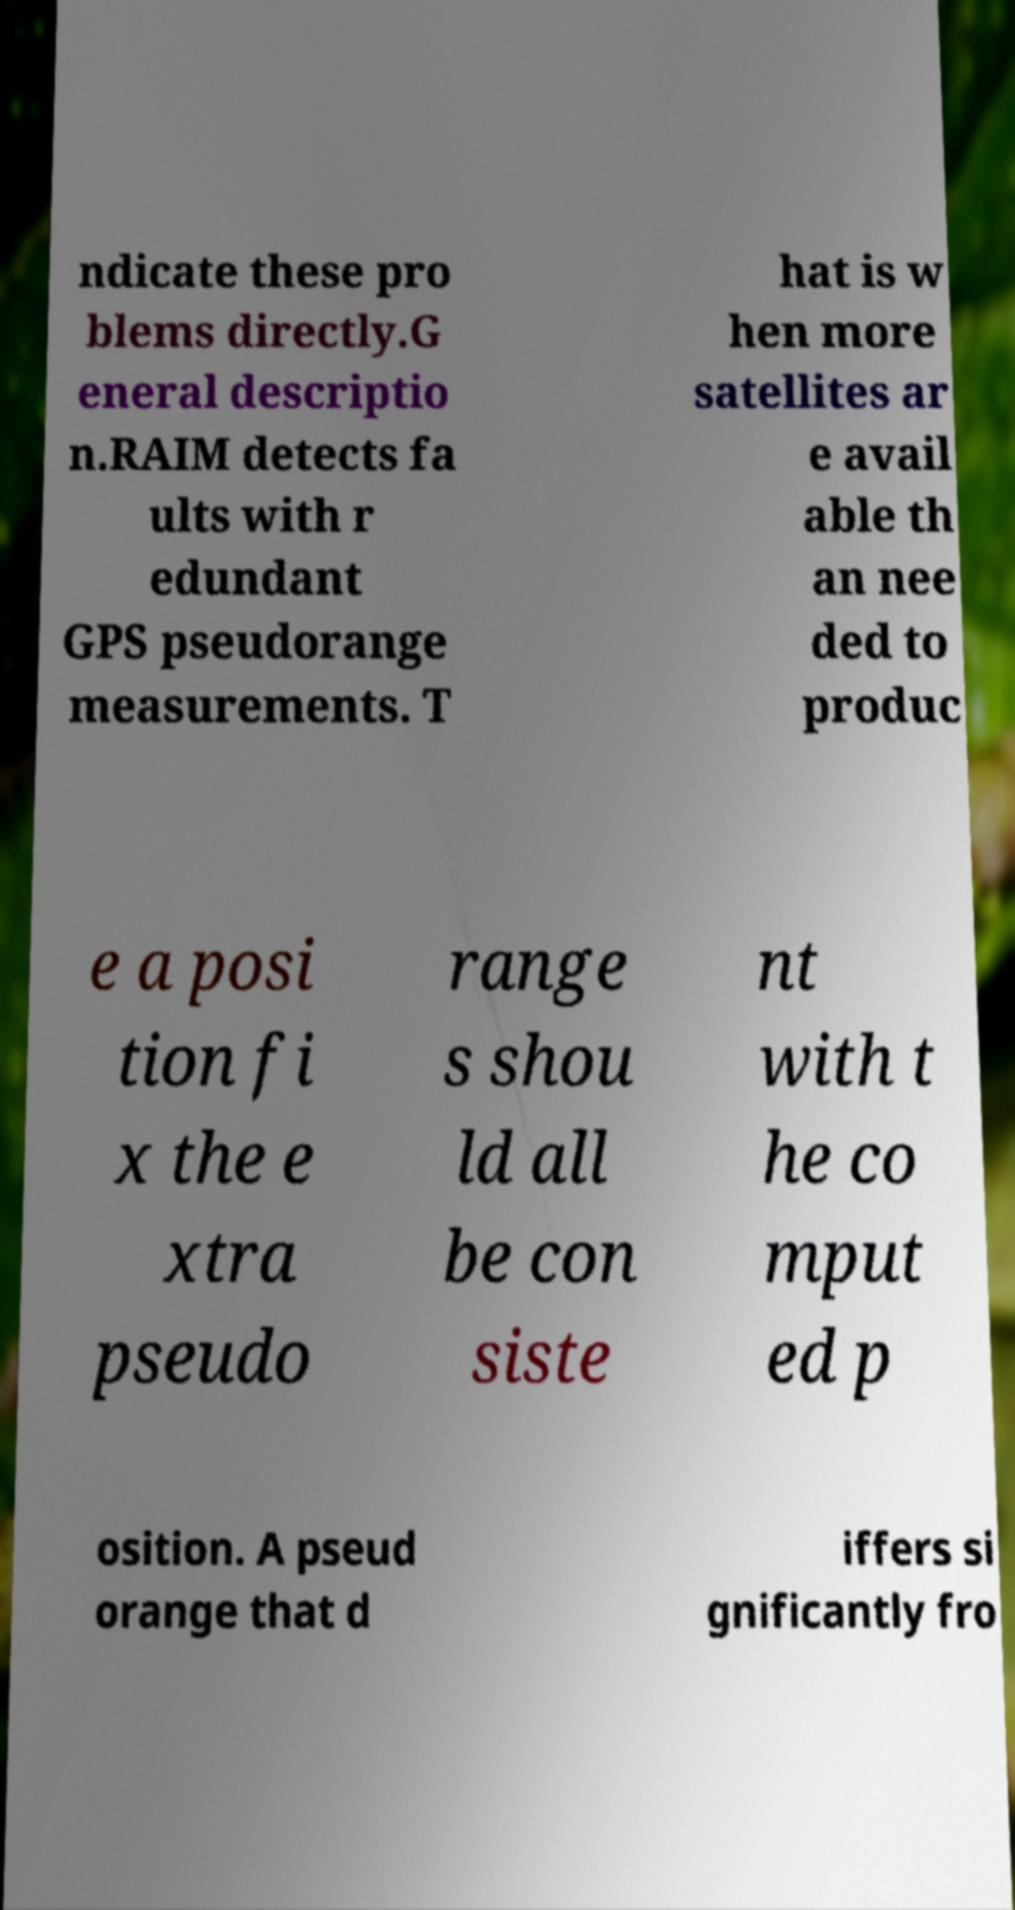What messages or text are displayed in this image? I need them in a readable, typed format. ndicate these pro blems directly.G eneral descriptio n.RAIM detects fa ults with r edundant GPS pseudorange measurements. T hat is w hen more satellites ar e avail able th an nee ded to produc e a posi tion fi x the e xtra pseudo range s shou ld all be con siste nt with t he co mput ed p osition. A pseud orange that d iffers si gnificantly fro 